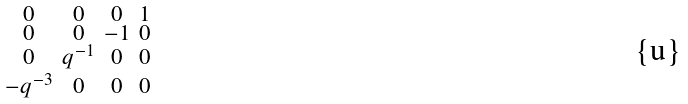<formula> <loc_0><loc_0><loc_500><loc_500>\begin{smallmatrix} 0 & 0 & 0 & 1 \\ 0 & 0 & - 1 & 0 \\ 0 & q ^ { - 1 } & 0 & 0 \\ - q ^ { - 3 } & 0 & 0 & 0 \end{smallmatrix}</formula> 